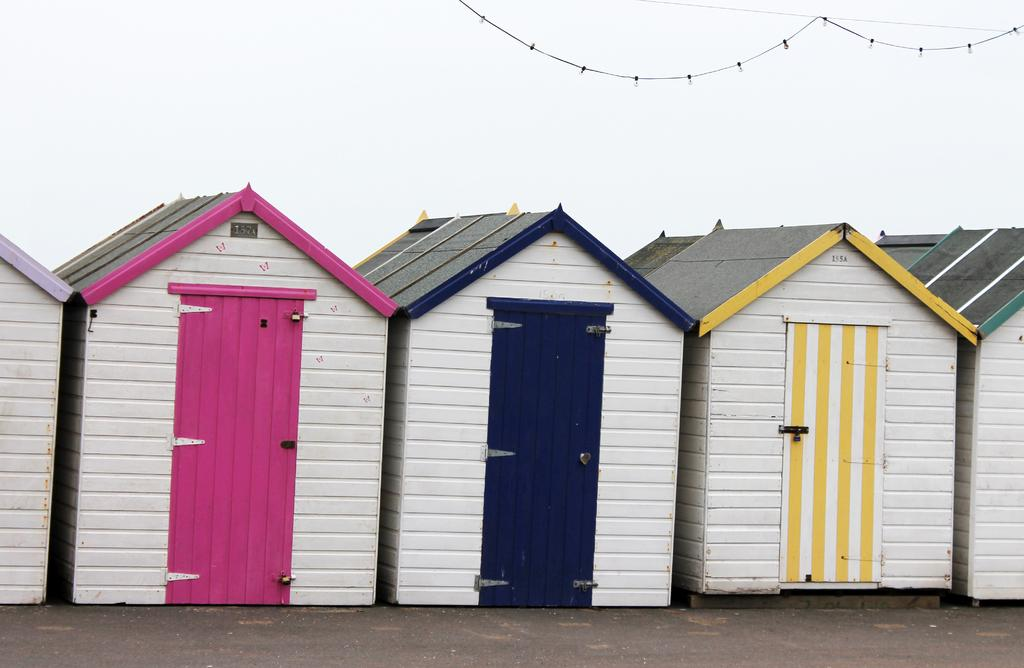What is the person in the image holding? The person is holding a surfboard. Where is the person standing in relation to the water? The person is standing near the water. How does the form of the surfboard change in the image? The surfboard does not change its form in the image; it remains the same. 